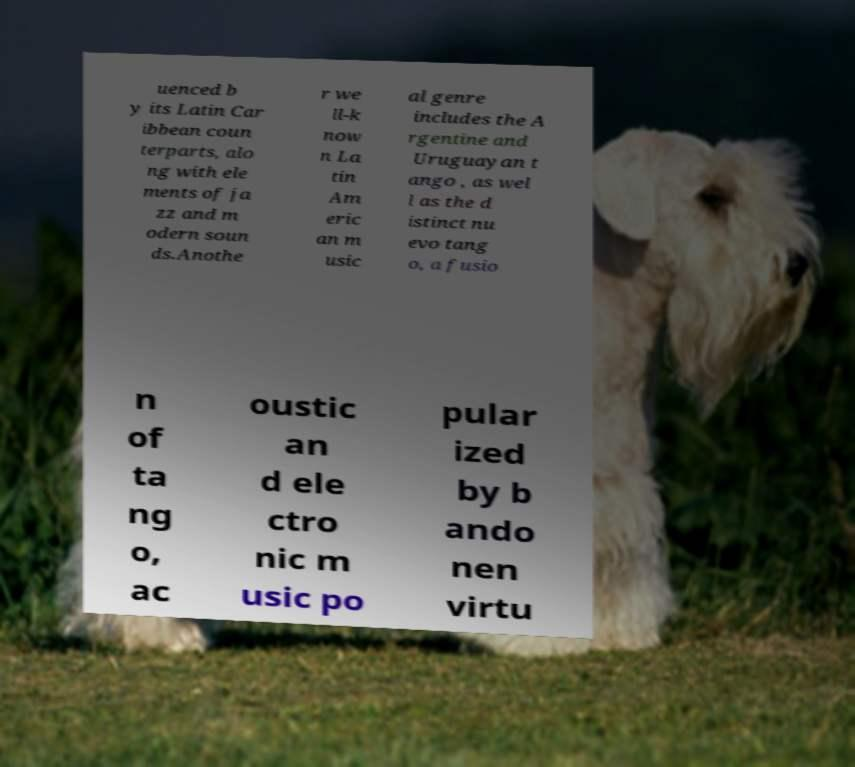What messages or text are displayed in this image? I need them in a readable, typed format. uenced b y its Latin Car ibbean coun terparts, alo ng with ele ments of ja zz and m odern soun ds.Anothe r we ll-k now n La tin Am eric an m usic al genre includes the A rgentine and Uruguayan t ango , as wel l as the d istinct nu evo tang o, a fusio n of ta ng o, ac oustic an d ele ctro nic m usic po pular ized by b ando nen virtu 